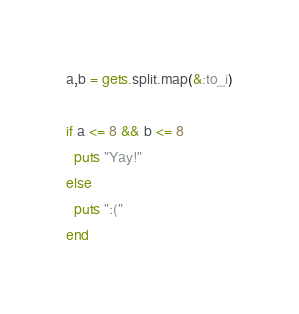<code> <loc_0><loc_0><loc_500><loc_500><_Ruby_>a,b = gets.split.map(&:to_i)

if a <= 8 && b <= 8
  puts "Yay!"
else
  puts ":("
end
</code> 